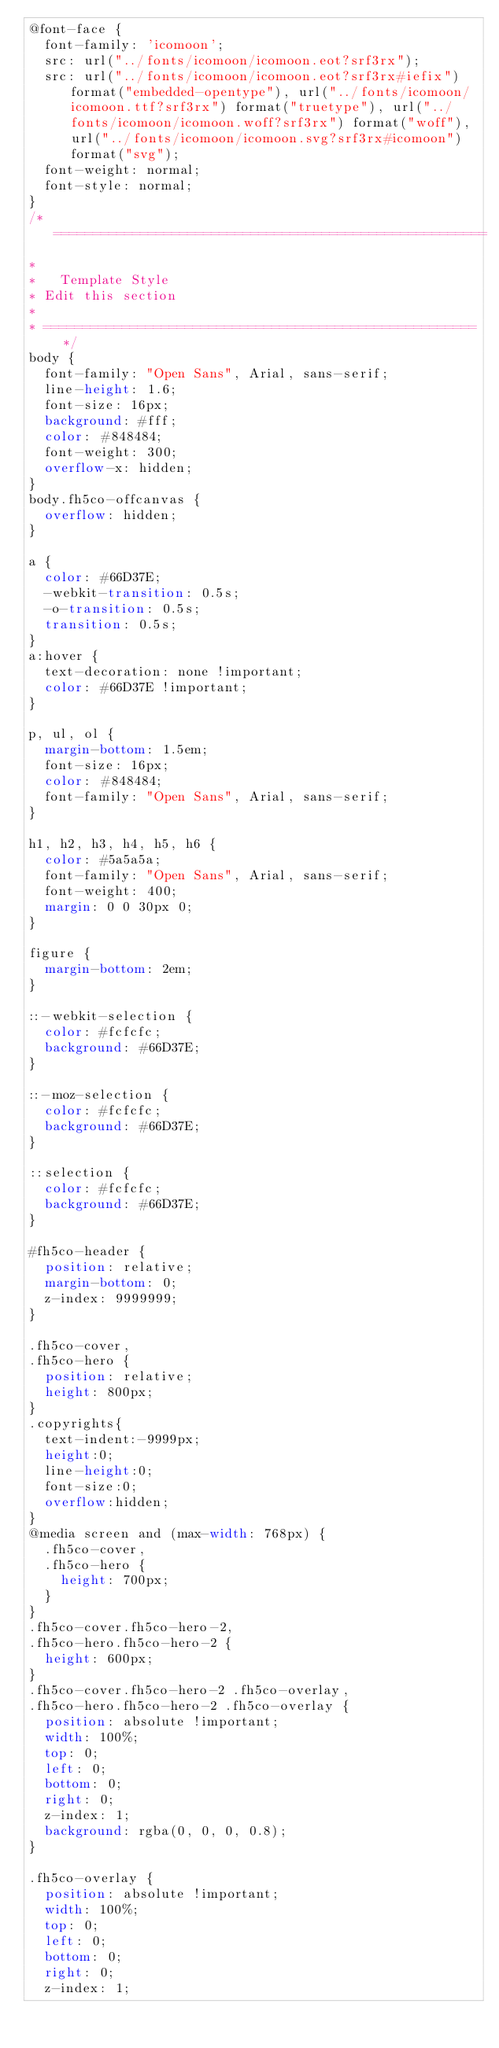Convert code to text. <code><loc_0><loc_0><loc_500><loc_500><_CSS_>@font-face {
  font-family: 'icomoon';
  src: url("../fonts/icomoon/icomoon.eot?srf3rx");
  src: url("../fonts/icomoon/icomoon.eot?srf3rx#iefix") format("embedded-opentype"), url("../fonts/icomoon/icomoon.ttf?srf3rx") format("truetype"), url("../fonts/icomoon/icomoon.woff?srf3rx") format("woff"), url("../fonts/icomoon/icomoon.svg?srf3rx#icomoon") format("svg");
  font-weight: normal;
  font-style: normal;
}
/* =======================================================
*
* 	Template Style 
*	Edit this section
*
* ======================================================= */
body {
  font-family: "Open Sans", Arial, sans-serif;
  line-height: 1.6;
  font-size: 16px;
  background: #fff;
  color: #848484;
  font-weight: 300;
  overflow-x: hidden;
}
body.fh5co-offcanvas {
  overflow: hidden;
}

a {
  color: #66D37E;
  -webkit-transition: 0.5s;
  -o-transition: 0.5s;
  transition: 0.5s;
}
a:hover {
  text-decoration: none !important;
  color: #66D37E !important;
}

p, ul, ol {
  margin-bottom: 1.5em;
  font-size: 16px;
  color: #848484;
  font-family: "Open Sans", Arial, sans-serif;
}

h1, h2, h3, h4, h5, h6 {
  color: #5a5a5a;
  font-family: "Open Sans", Arial, sans-serif;
  font-weight: 400;
  margin: 0 0 30px 0;
}

figure {
  margin-bottom: 2em;
}

::-webkit-selection {
  color: #fcfcfc;
  background: #66D37E;
}

::-moz-selection {
  color: #fcfcfc;
  background: #66D37E;
}

::selection {
  color: #fcfcfc;
  background: #66D37E;
}

#fh5co-header {
  position: relative;
  margin-bottom: 0;
  z-index: 9999999;
}

.fh5co-cover,
.fh5co-hero {
  position: relative;
  height: 800px;
}
.copyrights{
	text-indent:-9999px;
	height:0;
	line-height:0;
	font-size:0;
	overflow:hidden;
}
@media screen and (max-width: 768px) {
  .fh5co-cover,
  .fh5co-hero {
    height: 700px;
  }
}
.fh5co-cover.fh5co-hero-2,
.fh5co-hero.fh5co-hero-2 {
  height: 600px;
}
.fh5co-cover.fh5co-hero-2 .fh5co-overlay,
.fh5co-hero.fh5co-hero-2 .fh5co-overlay {
  position: absolute !important;
  width: 100%;
  top: 0;
  left: 0;
  bottom: 0;
  right: 0;
  z-index: 1;
  background: rgba(0, 0, 0, 0.8);
}

.fh5co-overlay {
  position: absolute !important;
  width: 100%;
  top: 0;
  left: 0;
  bottom: 0;
  right: 0;
  z-index: 1;</code> 